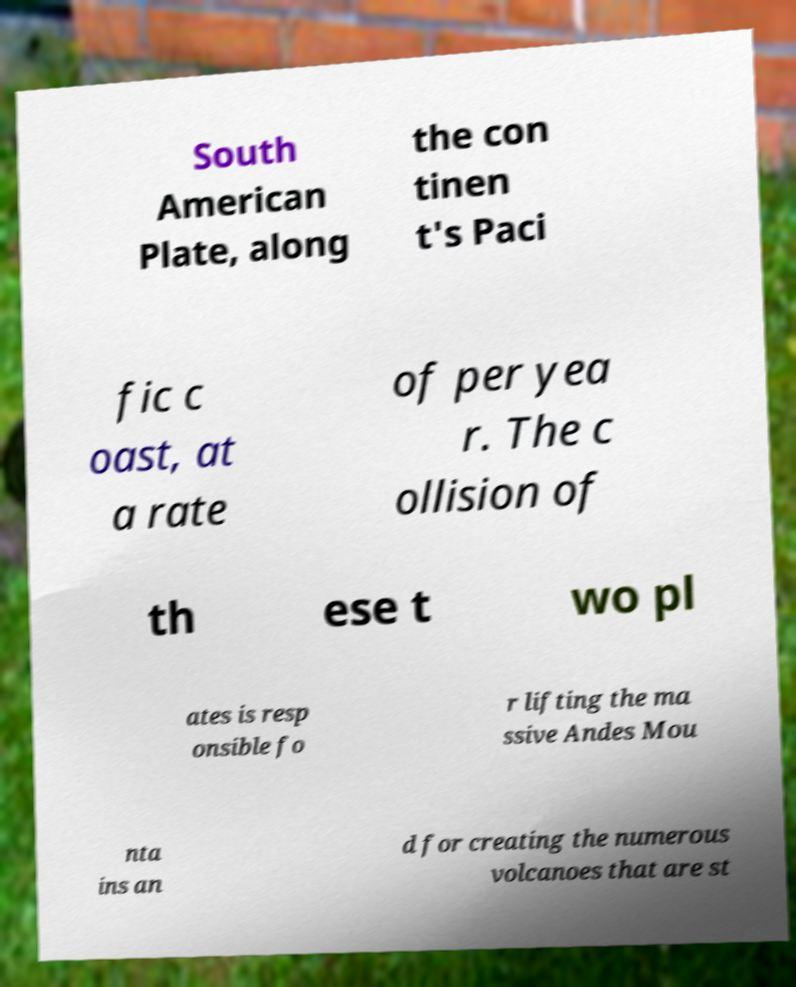Could you extract and type out the text from this image? South American Plate, along the con tinen t's Paci fic c oast, at a rate of per yea r. The c ollision of th ese t wo pl ates is resp onsible fo r lifting the ma ssive Andes Mou nta ins an d for creating the numerous volcanoes that are st 